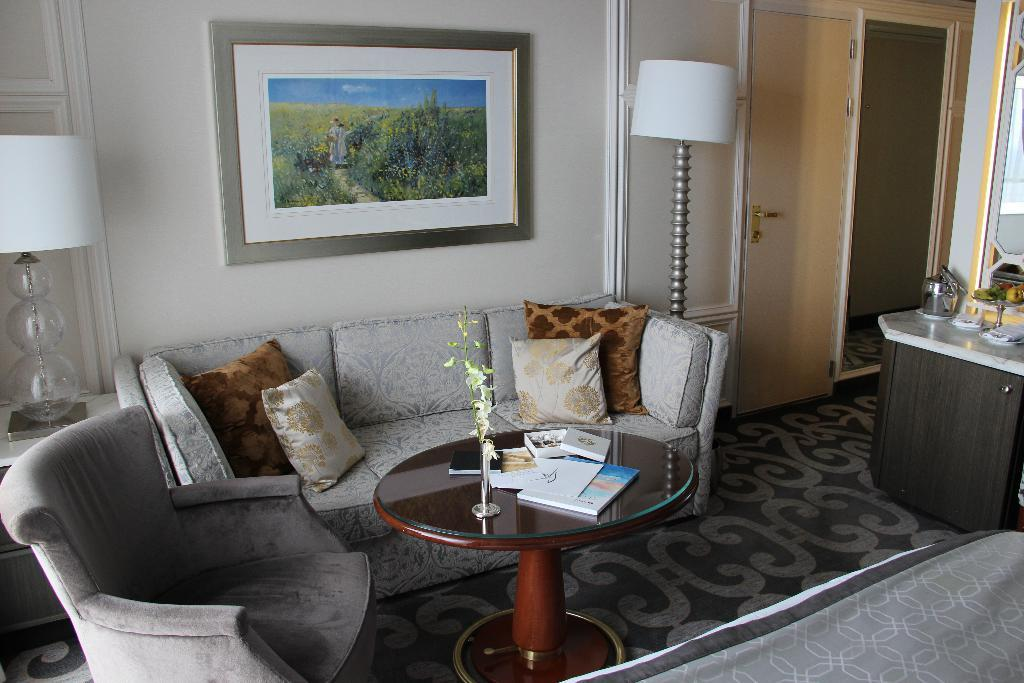What type of furniture is in the image? There is a sofa in the image. What is placed on the sofa? There are pillows on the sofa. What is located in front of the sofa? There is a table in front of the sofa. What items can be seen on the table? There are books and a plant on the table. What is hanging on the wall in the background? There is a photo frame on the wall in the background. What type of patch is visible on the sofa in the image? There is no patch visible on the sofa in the image. How many eggs are on the table in the image? There are no eggs present on the table in the image. 